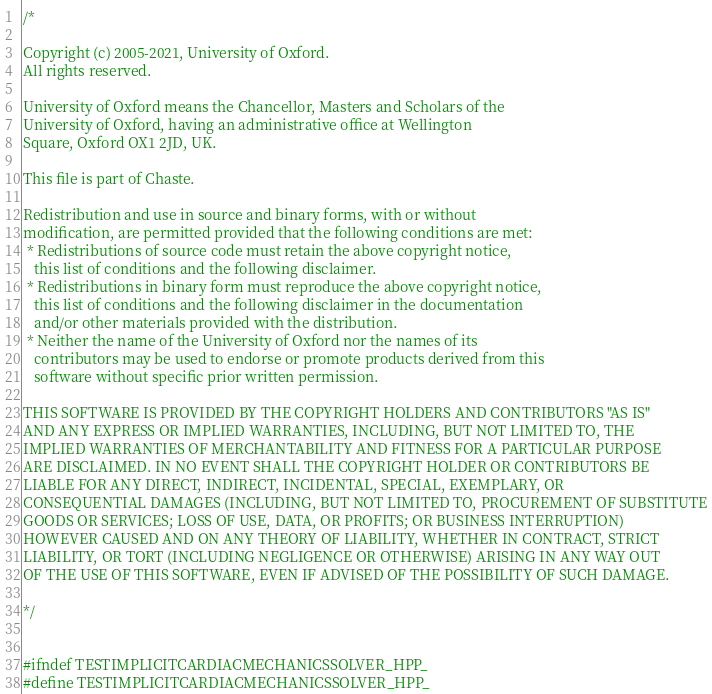<code> <loc_0><loc_0><loc_500><loc_500><_C++_>/*

Copyright (c) 2005-2021, University of Oxford.
All rights reserved.

University of Oxford means the Chancellor, Masters and Scholars of the
University of Oxford, having an administrative office at Wellington
Square, Oxford OX1 2JD, UK.

This file is part of Chaste.

Redistribution and use in source and binary forms, with or without
modification, are permitted provided that the following conditions are met:
 * Redistributions of source code must retain the above copyright notice,
   this list of conditions and the following disclaimer.
 * Redistributions in binary form must reproduce the above copyright notice,
   this list of conditions and the following disclaimer in the documentation
   and/or other materials provided with the distribution.
 * Neither the name of the University of Oxford nor the names of its
   contributors may be used to endorse or promote products derived from this
   software without specific prior written permission.

THIS SOFTWARE IS PROVIDED BY THE COPYRIGHT HOLDERS AND CONTRIBUTORS "AS IS"
AND ANY EXPRESS OR IMPLIED WARRANTIES, INCLUDING, BUT NOT LIMITED TO, THE
IMPLIED WARRANTIES OF MERCHANTABILITY AND FITNESS FOR A PARTICULAR PURPOSE
ARE DISCLAIMED. IN NO EVENT SHALL THE COPYRIGHT HOLDER OR CONTRIBUTORS BE
LIABLE FOR ANY DIRECT, INDIRECT, INCIDENTAL, SPECIAL, EXEMPLARY, OR
CONSEQUENTIAL DAMAGES (INCLUDING, BUT NOT LIMITED TO, PROCUREMENT OF SUBSTITUTE
GOODS OR SERVICES; LOSS OF USE, DATA, OR PROFITS; OR BUSINESS INTERRUPTION)
HOWEVER CAUSED AND ON ANY THEORY OF LIABILITY, WHETHER IN CONTRACT, STRICT
LIABILITY, OR TORT (INCLUDING NEGLIGENCE OR OTHERWISE) ARISING IN ANY WAY OUT
OF THE USE OF THIS SOFTWARE, EVEN IF ADVISED OF THE POSSIBILITY OF SUCH DAMAGE.

*/


#ifndef TESTIMPLICITCARDIACMECHANICSSOLVER_HPP_
#define TESTIMPLICITCARDIACMECHANICSSOLVER_HPP_
</code> 